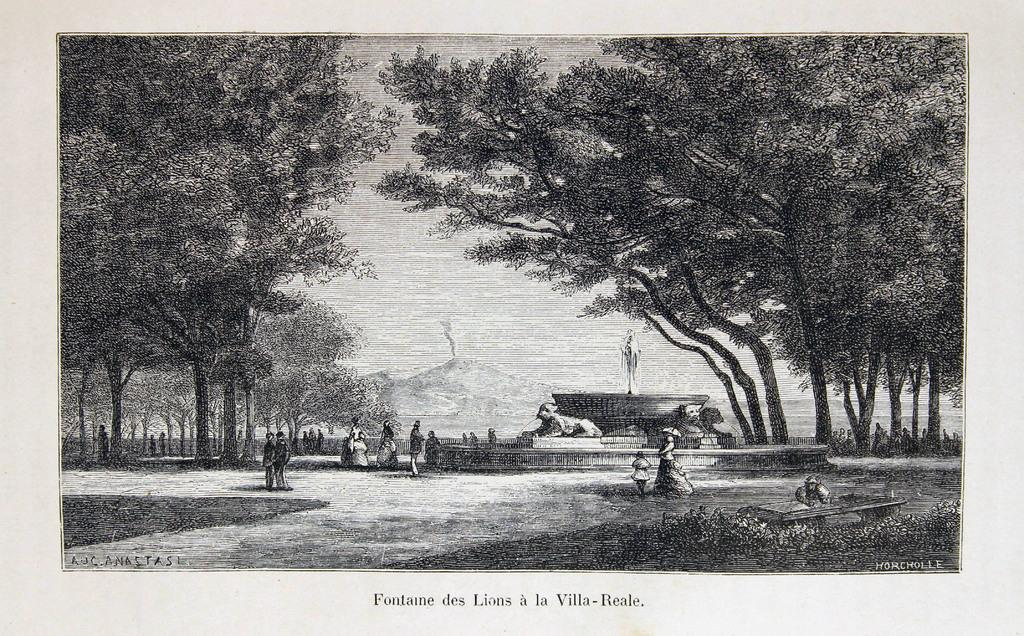How many people are in the image? There is a group of people in the image. What is the position of the people in the image? The people are on the ground. What type of vegetation can be seen in the image? There is grass in the image, and trees are also present. What type of structure is visible in the image? There is a statue in the image. What natural features can be seen in the image? There are mountains in the image. What is visible in the sky in the image? The sky is visible in the image. What type of ink is used to draw the mountains in the image? There is no ink present in the image, as the mountains are a natural feature. 